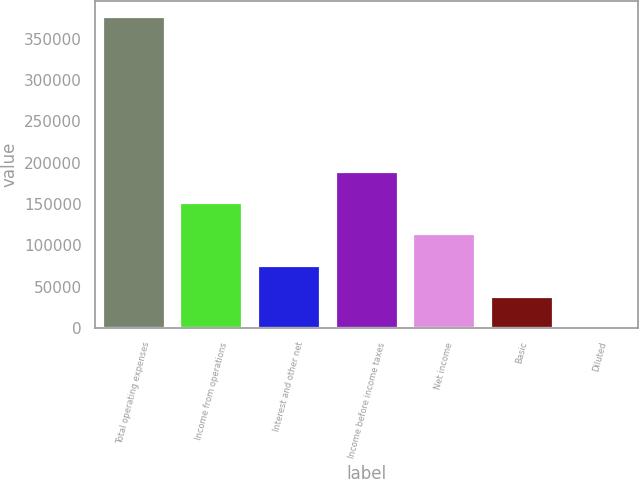Convert chart. <chart><loc_0><loc_0><loc_500><loc_500><bar_chart><fcel>Total operating expenses<fcel>Income from operations<fcel>Interest and other net<fcel>Income before income taxes<fcel>Net income<fcel>Basic<fcel>Diluted<nl><fcel>376824<fcel>150730<fcel>75365.2<fcel>188412<fcel>113048<fcel>37682.8<fcel>0.5<nl></chart> 